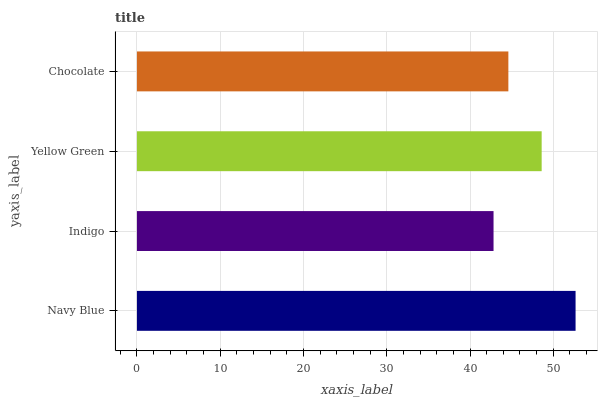Is Indigo the minimum?
Answer yes or no. Yes. Is Navy Blue the maximum?
Answer yes or no. Yes. Is Yellow Green the minimum?
Answer yes or no. No. Is Yellow Green the maximum?
Answer yes or no. No. Is Yellow Green greater than Indigo?
Answer yes or no. Yes. Is Indigo less than Yellow Green?
Answer yes or no. Yes. Is Indigo greater than Yellow Green?
Answer yes or no. No. Is Yellow Green less than Indigo?
Answer yes or no. No. Is Yellow Green the high median?
Answer yes or no. Yes. Is Chocolate the low median?
Answer yes or no. Yes. Is Chocolate the high median?
Answer yes or no. No. Is Indigo the low median?
Answer yes or no. No. 